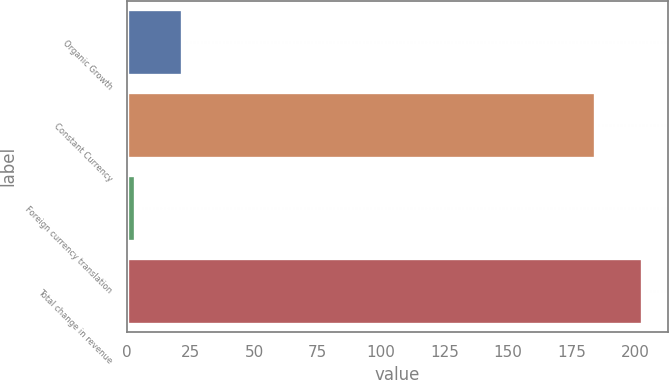<chart> <loc_0><loc_0><loc_500><loc_500><bar_chart><fcel>Organic Growth<fcel>Constant Currency<fcel>Foreign currency translation<fcel>Total change in revenue<nl><fcel>21.53<fcel>184.3<fcel>3.1<fcel>202.73<nl></chart> 